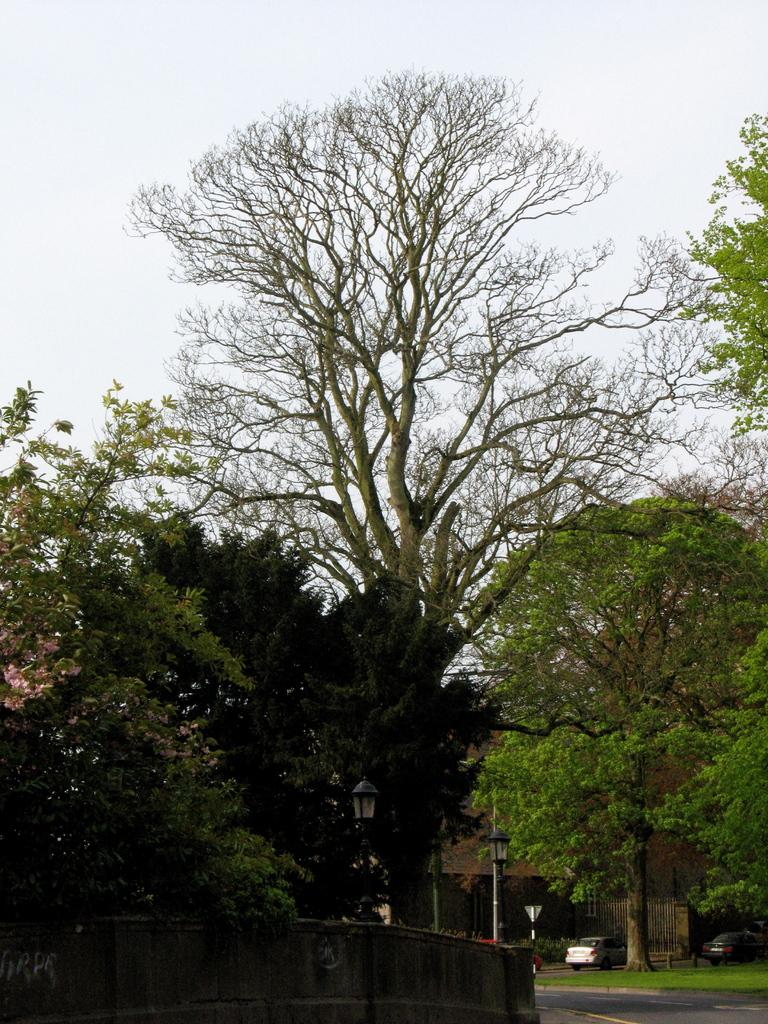What type of vegetation can be seen in the image? There are trees in the image. What structures are present in the image? There are poles, a wall, and a building in the image. What type of vehicles are visible in the image? There are cars in the image. What type of ground surface is present in the image? There is grass and a road in the image. What part of the natural environment is visible in the image? The sky is visible in the background of the image. Can you see a squirrel's tail in the image? There is no squirrel or tail present in the image. Where is the hall located in the image? There is no hall mentioned or visible in the image. 